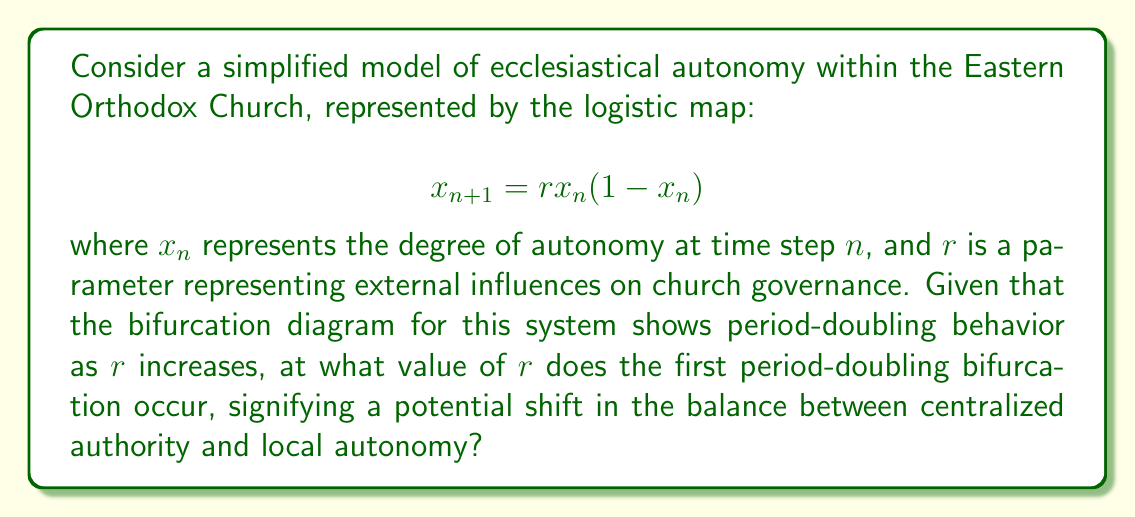Teach me how to tackle this problem. To solve this problem, we need to follow these steps:

1) The logistic map $x_{n+1} = rx_n(1-x_n)$ is a classic example in chaos theory that can model population dynamics, and in this case, ecclesiastical autonomy.

2) The first period-doubling bifurcation occurs when the system transitions from a stable fixed point to a 2-cycle.

3) To find this point, we need to solve for the stability of the fixed points. The fixed points are found by setting $x_{n+1} = x_n = x^*$:

   $$x^* = rx^*(1-x^*)$$

4) Solving this equation gives two fixed points: $x^* = 0$ and $x^* = 1 - \frac{1}{r}$.

5) The stability of these fixed points changes with $r$. The non-zero fixed point loses stability when:

   $$\left|\frac{d}{dx}(rx(1-x))\right|_{x=x^*} = |2-r| = 1$$

6) Solving this equation:

   $$2-r = 1$$ or $$2-r = -1$$

7) The first period-doubling bifurcation occurs at the larger solution:

   $$2-r = -1$$
   $$r = 3$$

This value of $r=3$ represents the critical point where the system transitions from a stable fixed point to a 2-cycle, potentially signifying a shift in the balance of ecclesiastical governance.
Answer: $r = 3$ 